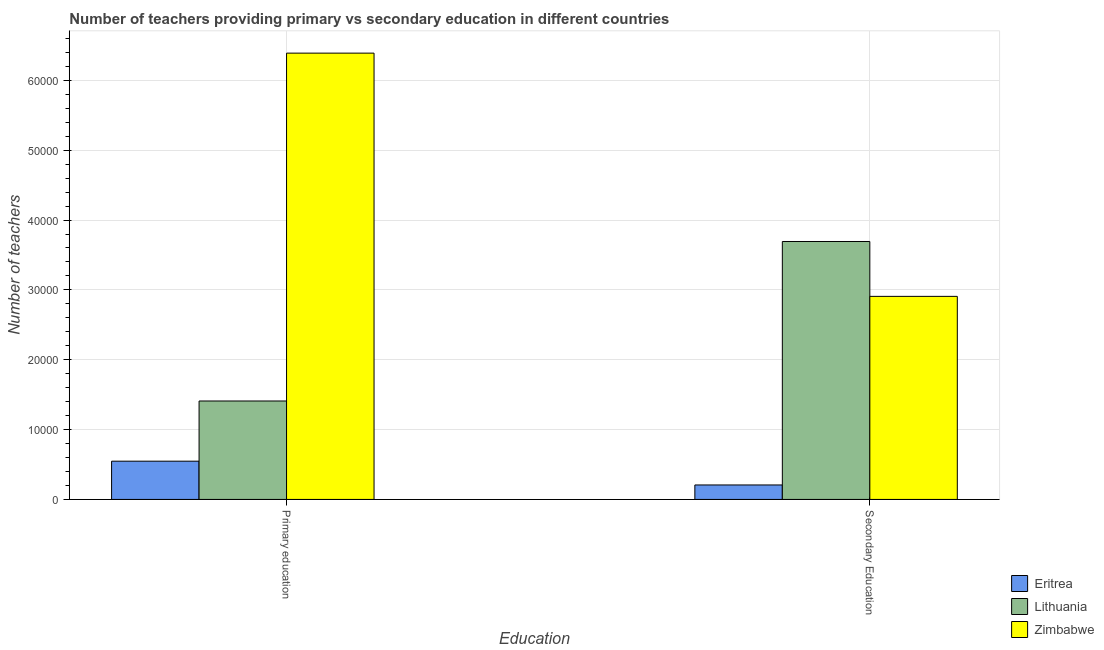How many different coloured bars are there?
Offer a terse response. 3. How many groups of bars are there?
Make the answer very short. 2. Are the number of bars per tick equal to the number of legend labels?
Provide a short and direct response. Yes. Are the number of bars on each tick of the X-axis equal?
Your answer should be compact. Yes. How many bars are there on the 1st tick from the left?
Offer a very short reply. 3. How many bars are there on the 2nd tick from the right?
Your answer should be very brief. 3. What is the label of the 2nd group of bars from the left?
Your answer should be very brief. Secondary Education. What is the number of primary teachers in Lithuania?
Your answer should be very brief. 1.41e+04. Across all countries, what is the maximum number of primary teachers?
Provide a succinct answer. 6.39e+04. Across all countries, what is the minimum number of primary teachers?
Keep it short and to the point. 5476. In which country was the number of secondary teachers maximum?
Give a very brief answer. Lithuania. In which country was the number of secondary teachers minimum?
Provide a succinct answer. Eritrea. What is the total number of primary teachers in the graph?
Your answer should be compact. 8.35e+04. What is the difference between the number of secondary teachers in Eritrea and that in Zimbabwe?
Your response must be concise. -2.70e+04. What is the difference between the number of secondary teachers in Zimbabwe and the number of primary teachers in Lithuania?
Make the answer very short. 1.50e+04. What is the average number of secondary teachers per country?
Offer a very short reply. 2.27e+04. What is the difference between the number of secondary teachers and number of primary teachers in Eritrea?
Give a very brief answer. -3405. What is the ratio of the number of secondary teachers in Eritrea to that in Zimbabwe?
Give a very brief answer. 0.07. Is the number of secondary teachers in Zimbabwe less than that in Lithuania?
Your response must be concise. Yes. In how many countries, is the number of primary teachers greater than the average number of primary teachers taken over all countries?
Offer a terse response. 1. What does the 2nd bar from the left in Primary education represents?
Your answer should be compact. Lithuania. What does the 2nd bar from the right in Secondary Education represents?
Provide a short and direct response. Lithuania. How many bars are there?
Offer a terse response. 6. Are all the bars in the graph horizontal?
Make the answer very short. No. What is the difference between two consecutive major ticks on the Y-axis?
Provide a short and direct response. 10000. Are the values on the major ticks of Y-axis written in scientific E-notation?
Provide a short and direct response. No. Does the graph contain any zero values?
Provide a succinct answer. No. Where does the legend appear in the graph?
Make the answer very short. Bottom right. How are the legend labels stacked?
Ensure brevity in your answer.  Vertical. What is the title of the graph?
Your response must be concise. Number of teachers providing primary vs secondary education in different countries. What is the label or title of the X-axis?
Ensure brevity in your answer.  Education. What is the label or title of the Y-axis?
Your response must be concise. Number of teachers. What is the Number of teachers of Eritrea in Primary education?
Your response must be concise. 5476. What is the Number of teachers of Lithuania in Primary education?
Keep it short and to the point. 1.41e+04. What is the Number of teachers of Zimbabwe in Primary education?
Make the answer very short. 6.39e+04. What is the Number of teachers in Eritrea in Secondary Education?
Ensure brevity in your answer.  2071. What is the Number of teachers in Lithuania in Secondary Education?
Give a very brief answer. 3.69e+04. What is the Number of teachers in Zimbabwe in Secondary Education?
Your response must be concise. 2.91e+04. Across all Education, what is the maximum Number of teachers in Eritrea?
Provide a short and direct response. 5476. Across all Education, what is the maximum Number of teachers of Lithuania?
Offer a terse response. 3.69e+04. Across all Education, what is the maximum Number of teachers in Zimbabwe?
Provide a succinct answer. 6.39e+04. Across all Education, what is the minimum Number of teachers of Eritrea?
Make the answer very short. 2071. Across all Education, what is the minimum Number of teachers in Lithuania?
Your response must be concise. 1.41e+04. Across all Education, what is the minimum Number of teachers of Zimbabwe?
Give a very brief answer. 2.91e+04. What is the total Number of teachers of Eritrea in the graph?
Make the answer very short. 7547. What is the total Number of teachers in Lithuania in the graph?
Your answer should be very brief. 5.10e+04. What is the total Number of teachers in Zimbabwe in the graph?
Keep it short and to the point. 9.30e+04. What is the difference between the Number of teachers of Eritrea in Primary education and that in Secondary Education?
Provide a succinct answer. 3405. What is the difference between the Number of teachers of Lithuania in Primary education and that in Secondary Education?
Your response must be concise. -2.28e+04. What is the difference between the Number of teachers of Zimbabwe in Primary education and that in Secondary Education?
Keep it short and to the point. 3.48e+04. What is the difference between the Number of teachers in Eritrea in Primary education and the Number of teachers in Lithuania in Secondary Education?
Ensure brevity in your answer.  -3.15e+04. What is the difference between the Number of teachers of Eritrea in Primary education and the Number of teachers of Zimbabwe in Secondary Education?
Give a very brief answer. -2.36e+04. What is the difference between the Number of teachers in Lithuania in Primary education and the Number of teachers in Zimbabwe in Secondary Education?
Give a very brief answer. -1.50e+04. What is the average Number of teachers of Eritrea per Education?
Your answer should be compact. 3773.5. What is the average Number of teachers in Lithuania per Education?
Provide a succinct answer. 2.55e+04. What is the average Number of teachers in Zimbabwe per Education?
Provide a short and direct response. 4.65e+04. What is the difference between the Number of teachers in Eritrea and Number of teachers in Lithuania in Primary education?
Your response must be concise. -8619. What is the difference between the Number of teachers of Eritrea and Number of teachers of Zimbabwe in Primary education?
Your response must be concise. -5.84e+04. What is the difference between the Number of teachers of Lithuania and Number of teachers of Zimbabwe in Primary education?
Keep it short and to the point. -4.98e+04. What is the difference between the Number of teachers in Eritrea and Number of teachers in Lithuania in Secondary Education?
Give a very brief answer. -3.49e+04. What is the difference between the Number of teachers of Eritrea and Number of teachers of Zimbabwe in Secondary Education?
Give a very brief answer. -2.70e+04. What is the difference between the Number of teachers of Lithuania and Number of teachers of Zimbabwe in Secondary Education?
Make the answer very short. 7858. What is the ratio of the Number of teachers in Eritrea in Primary education to that in Secondary Education?
Provide a short and direct response. 2.64. What is the ratio of the Number of teachers of Lithuania in Primary education to that in Secondary Education?
Provide a succinct answer. 0.38. What is the ratio of the Number of teachers in Zimbabwe in Primary education to that in Secondary Education?
Your response must be concise. 2.2. What is the difference between the highest and the second highest Number of teachers in Eritrea?
Offer a very short reply. 3405. What is the difference between the highest and the second highest Number of teachers of Lithuania?
Offer a very short reply. 2.28e+04. What is the difference between the highest and the second highest Number of teachers of Zimbabwe?
Provide a succinct answer. 3.48e+04. What is the difference between the highest and the lowest Number of teachers in Eritrea?
Your answer should be compact. 3405. What is the difference between the highest and the lowest Number of teachers of Lithuania?
Your response must be concise. 2.28e+04. What is the difference between the highest and the lowest Number of teachers of Zimbabwe?
Offer a terse response. 3.48e+04. 